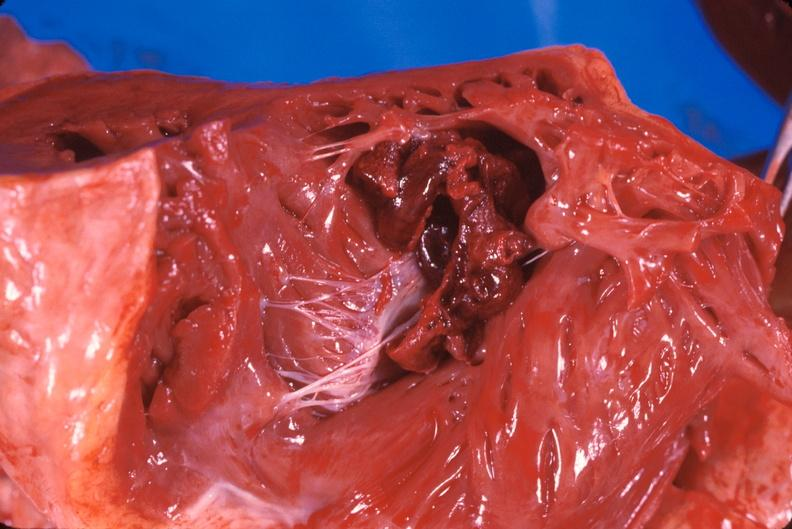does this image show thromboembolus from leg veins in right ventricle and atrium?
Answer the question using a single word or phrase. Yes 